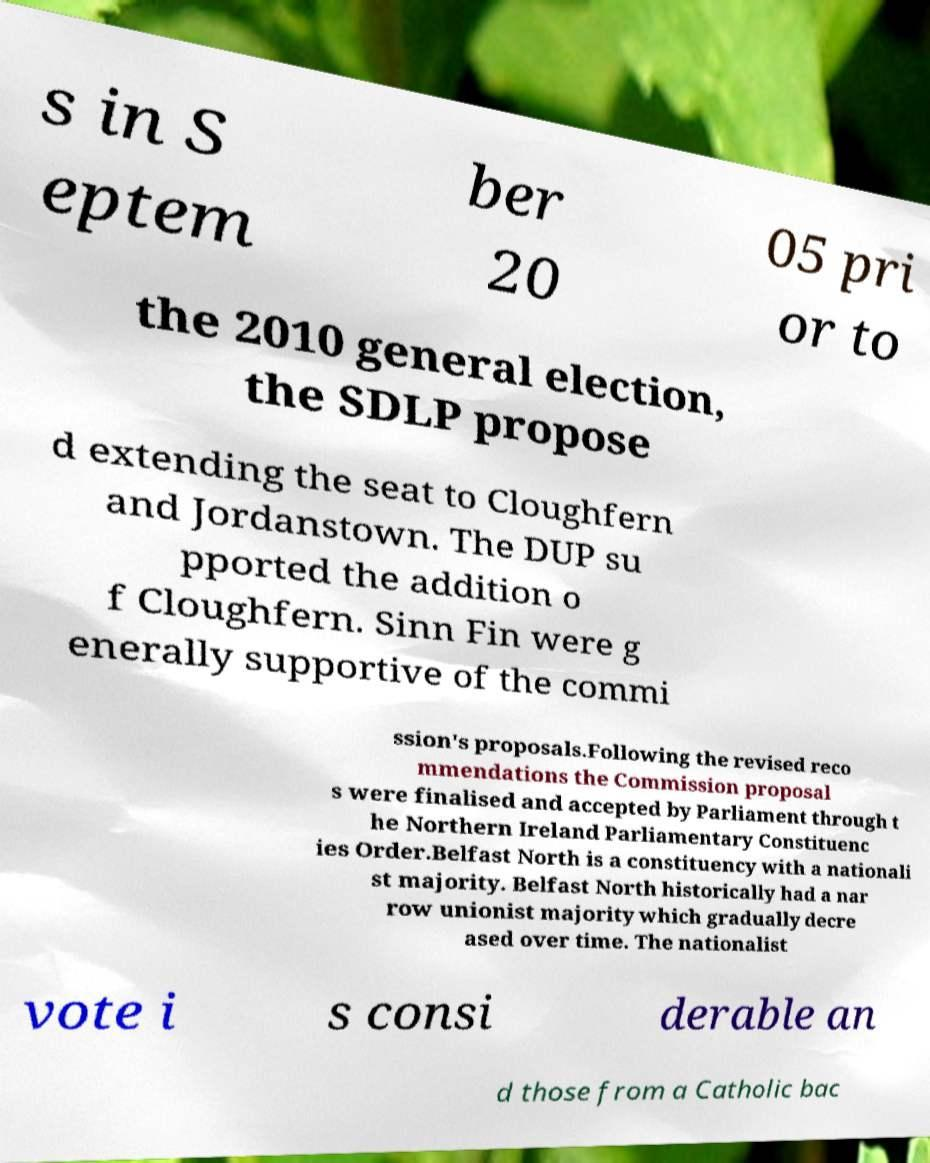Please identify and transcribe the text found in this image. s in S eptem ber 20 05 pri or to the 2010 general election, the SDLP propose d extending the seat to Cloughfern and Jordanstown. The DUP su pported the addition o f Cloughfern. Sinn Fin were g enerally supportive of the commi ssion's proposals.Following the revised reco mmendations the Commission proposal s were finalised and accepted by Parliament through t he Northern Ireland Parliamentary Constituenc ies Order.Belfast North is a constituency with a nationali st majority. Belfast North historically had a nar row unionist majority which gradually decre ased over time. The nationalist vote i s consi derable an d those from a Catholic bac 